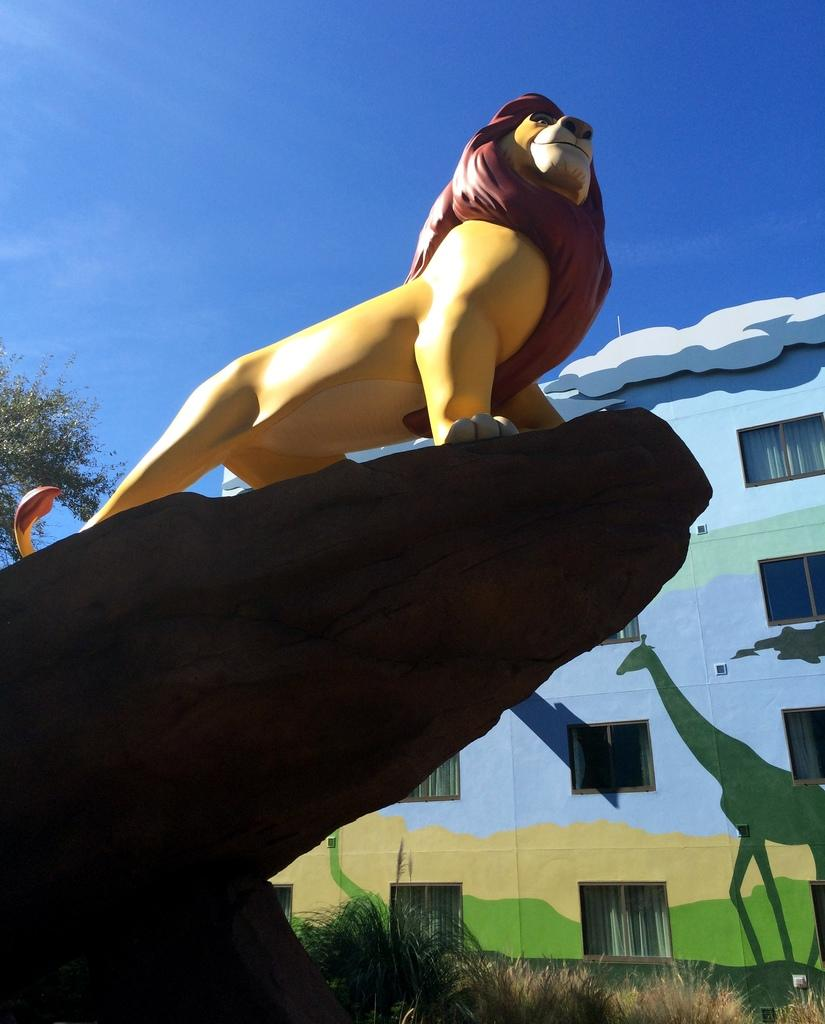What is the main subject of the image? There is a sculpture of a lion in the image. What can be seen in the background of the image? There is a tree, a building, the sky, grass, and other objects visible in the background of the image. How does the lion care for the rat in the image? There is no rat present in the image, and the lion is a sculpture, so it cannot care for any animals. 